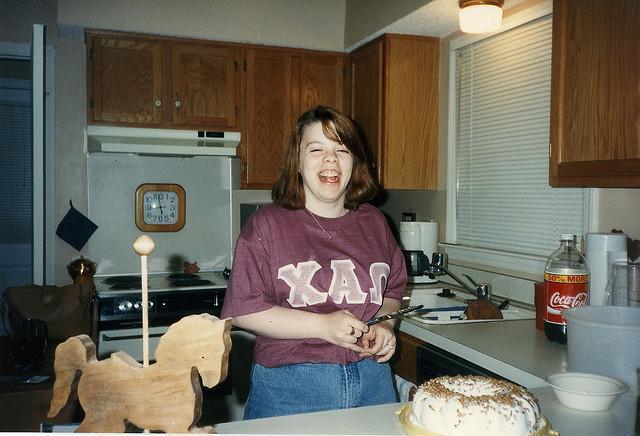What soda does she like to drink?
Choose the right answer from the provided options to respond to the question.
Options: Fanta, coca-cola, sprite, mountain dew. Coca-cola. 